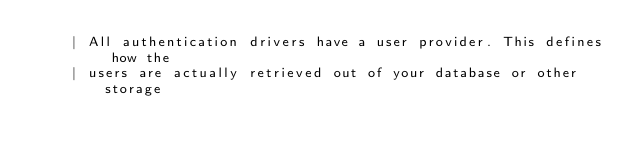Convert code to text. <code><loc_0><loc_0><loc_500><loc_500><_PHP_>    | All authentication drivers have a user provider. This defines how the
    | users are actually retrieved out of your database or other storage</code> 